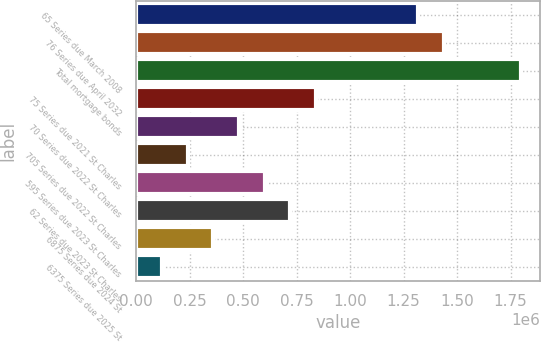<chart> <loc_0><loc_0><loc_500><loc_500><bar_chart><fcel>65 Series due March 2008<fcel>76 Series due April 2032<fcel>Total mortgage bonds<fcel>75 Series due 2021 St Charles<fcel>70 Series due 2022 St Charles<fcel>705 Series due 2022 St Charles<fcel>595 Series due 2023 St Charles<fcel>62 Series due 2023 St Charles<fcel>6875 Series due 2024 St<fcel>6375 Series due 2025 St<nl><fcel>1.31844e+06<fcel>1.43816e+06<fcel>1.79732e+06<fcel>839558<fcel>480397<fcel>240957<fcel>600118<fcel>719838<fcel>360677<fcel>121236<nl></chart> 